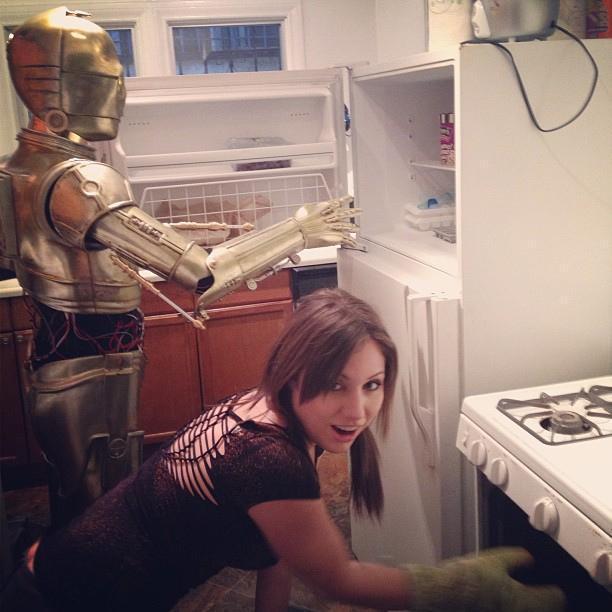How many people are there?
Give a very brief answer. 1. 